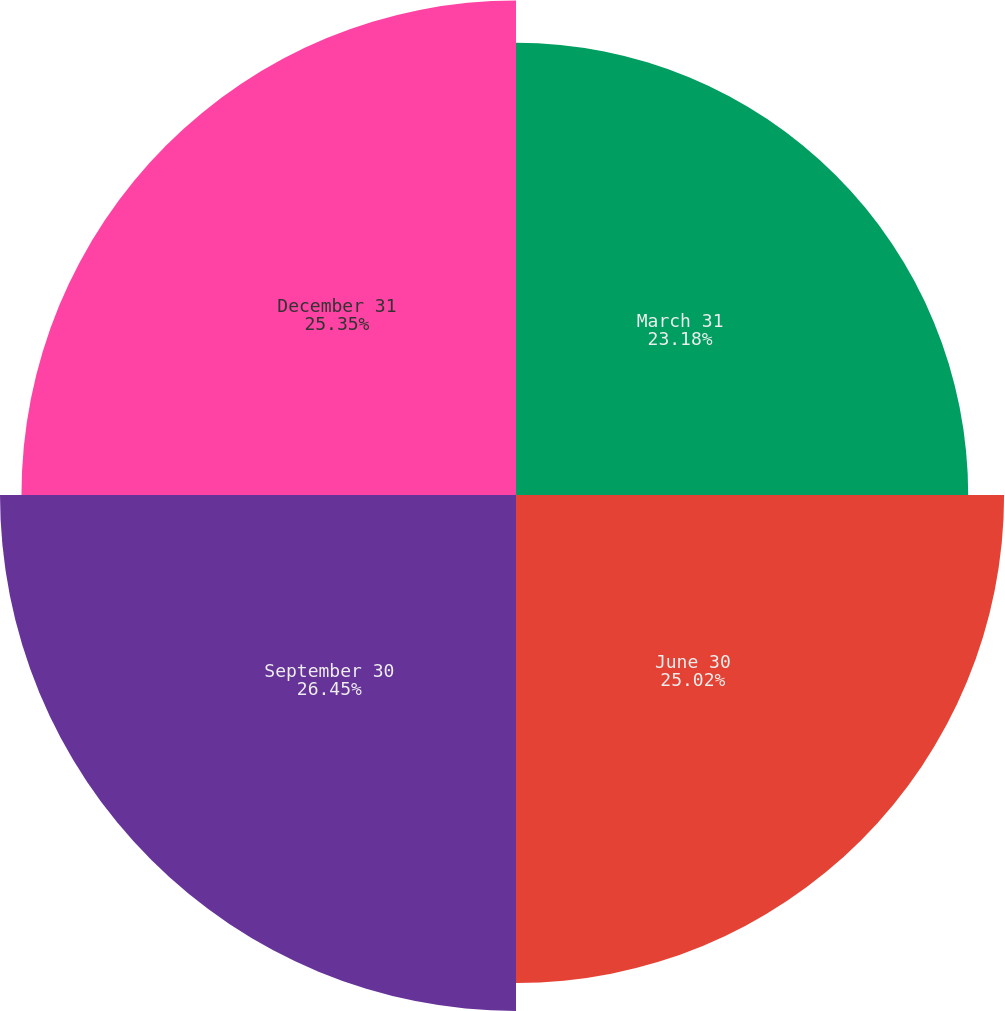Convert chart. <chart><loc_0><loc_0><loc_500><loc_500><pie_chart><fcel>March 31<fcel>June 30<fcel>September 30<fcel>December 31<nl><fcel>23.18%<fcel>25.02%<fcel>26.45%<fcel>25.35%<nl></chart> 